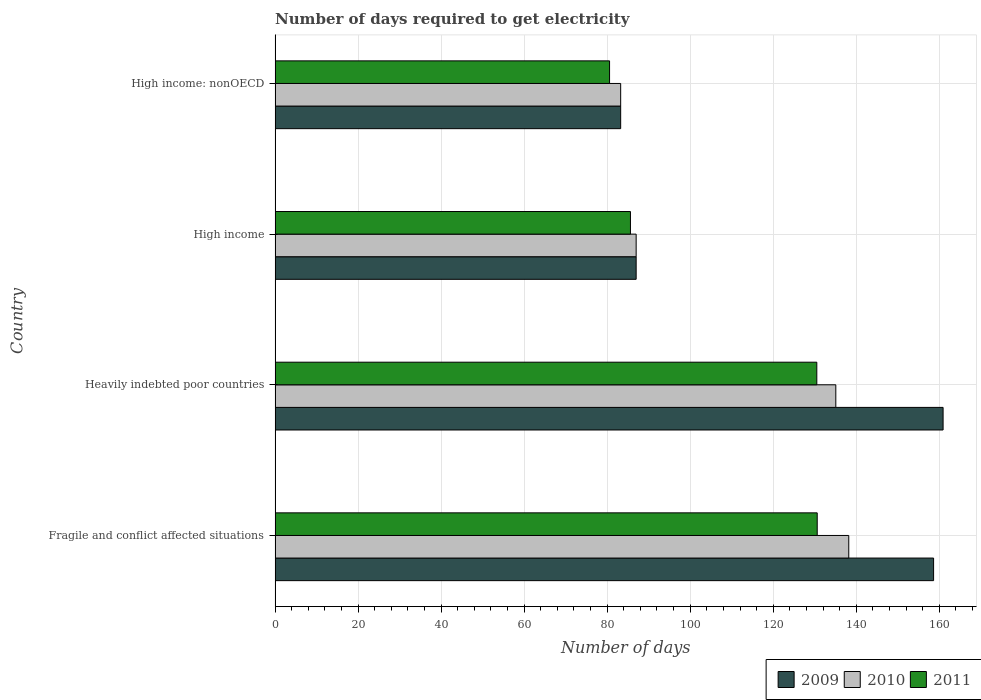Are the number of bars per tick equal to the number of legend labels?
Provide a short and direct response. Yes. Are the number of bars on each tick of the Y-axis equal?
Provide a succinct answer. Yes. How many bars are there on the 2nd tick from the bottom?
Make the answer very short. 3. What is the label of the 3rd group of bars from the top?
Give a very brief answer. Heavily indebted poor countries. What is the number of days required to get electricity in in 2011 in Fragile and conflict affected situations?
Your answer should be compact. 130.6. Across all countries, what is the maximum number of days required to get electricity in in 2011?
Give a very brief answer. 130.6. Across all countries, what is the minimum number of days required to get electricity in in 2011?
Give a very brief answer. 80.58. In which country was the number of days required to get electricity in in 2009 maximum?
Provide a short and direct response. Heavily indebted poor countries. In which country was the number of days required to get electricity in in 2009 minimum?
Offer a very short reply. High income: nonOECD. What is the total number of days required to get electricity in in 2011 in the graph?
Provide a succinct answer. 427.28. What is the difference between the number of days required to get electricity in in 2010 in Fragile and conflict affected situations and that in Heavily indebted poor countries?
Ensure brevity in your answer.  3.12. What is the difference between the number of days required to get electricity in in 2009 in Heavily indebted poor countries and the number of days required to get electricity in in 2010 in Fragile and conflict affected situations?
Your response must be concise. 22.72. What is the average number of days required to get electricity in in 2011 per country?
Offer a terse response. 106.82. What is the difference between the number of days required to get electricity in in 2011 and number of days required to get electricity in in 2009 in High income?
Make the answer very short. -1.37. What is the ratio of the number of days required to get electricity in in 2011 in Heavily indebted poor countries to that in High income: nonOECD?
Provide a succinct answer. 1.62. Is the number of days required to get electricity in in 2010 in Fragile and conflict affected situations less than that in Heavily indebted poor countries?
Provide a short and direct response. No. Is the difference between the number of days required to get electricity in in 2011 in Fragile and conflict affected situations and High income greater than the difference between the number of days required to get electricity in in 2009 in Fragile and conflict affected situations and High income?
Your response must be concise. No. What is the difference between the highest and the second highest number of days required to get electricity in in 2009?
Keep it short and to the point. 2.29. What is the difference between the highest and the lowest number of days required to get electricity in in 2011?
Give a very brief answer. 50.02. Is the sum of the number of days required to get electricity in in 2009 in Fragile and conflict affected situations and High income greater than the maximum number of days required to get electricity in in 2011 across all countries?
Provide a succinct answer. Yes. What does the 2nd bar from the bottom in High income: nonOECD represents?
Give a very brief answer. 2010. How many bars are there?
Your answer should be compact. 12. Does the graph contain grids?
Offer a very short reply. Yes. Where does the legend appear in the graph?
Your answer should be very brief. Bottom right. How many legend labels are there?
Your response must be concise. 3. What is the title of the graph?
Your answer should be very brief. Number of days required to get electricity. Does "2007" appear as one of the legend labels in the graph?
Your answer should be compact. No. What is the label or title of the X-axis?
Make the answer very short. Number of days. What is the Number of days in 2009 in Fragile and conflict affected situations?
Ensure brevity in your answer.  158.63. What is the Number of days in 2010 in Fragile and conflict affected situations?
Your answer should be compact. 138.2. What is the Number of days of 2011 in Fragile and conflict affected situations?
Keep it short and to the point. 130.6. What is the Number of days in 2009 in Heavily indebted poor countries?
Offer a very short reply. 160.92. What is the Number of days in 2010 in Heavily indebted poor countries?
Provide a short and direct response. 135.08. What is the Number of days of 2011 in Heavily indebted poor countries?
Your answer should be compact. 130.5. What is the Number of days in 2009 in High income?
Offer a very short reply. 86.98. What is the Number of days of 2010 in High income?
Make the answer very short. 86.98. What is the Number of days in 2011 in High income?
Your answer should be very brief. 85.61. What is the Number of days of 2009 in High income: nonOECD?
Your answer should be very brief. 83.25. What is the Number of days in 2010 in High income: nonOECD?
Provide a short and direct response. 83.25. What is the Number of days of 2011 in High income: nonOECD?
Keep it short and to the point. 80.58. Across all countries, what is the maximum Number of days in 2009?
Provide a succinct answer. 160.92. Across all countries, what is the maximum Number of days of 2010?
Your answer should be compact. 138.2. Across all countries, what is the maximum Number of days in 2011?
Provide a succinct answer. 130.6. Across all countries, what is the minimum Number of days of 2009?
Your answer should be very brief. 83.25. Across all countries, what is the minimum Number of days in 2010?
Offer a very short reply. 83.25. Across all countries, what is the minimum Number of days of 2011?
Ensure brevity in your answer.  80.58. What is the total Number of days in 2009 in the graph?
Your answer should be compact. 489.79. What is the total Number of days in 2010 in the graph?
Offer a terse response. 443.51. What is the total Number of days of 2011 in the graph?
Ensure brevity in your answer.  427.28. What is the difference between the Number of days in 2009 in Fragile and conflict affected situations and that in Heavily indebted poor countries?
Offer a very short reply. -2.29. What is the difference between the Number of days in 2010 in Fragile and conflict affected situations and that in Heavily indebted poor countries?
Provide a short and direct response. 3.12. What is the difference between the Number of days in 2011 in Fragile and conflict affected situations and that in Heavily indebted poor countries?
Your answer should be very brief. 0.1. What is the difference between the Number of days of 2009 in Fragile and conflict affected situations and that in High income?
Ensure brevity in your answer.  71.65. What is the difference between the Number of days of 2010 in Fragile and conflict affected situations and that in High income?
Your answer should be compact. 51.22. What is the difference between the Number of days in 2011 in Fragile and conflict affected situations and that in High income?
Ensure brevity in your answer.  44.99. What is the difference between the Number of days of 2009 in Fragile and conflict affected situations and that in High income: nonOECD?
Give a very brief answer. 75.38. What is the difference between the Number of days in 2010 in Fragile and conflict affected situations and that in High income: nonOECD?
Provide a succinct answer. 54.95. What is the difference between the Number of days of 2011 in Fragile and conflict affected situations and that in High income: nonOECD?
Offer a terse response. 50.02. What is the difference between the Number of days in 2009 in Heavily indebted poor countries and that in High income?
Ensure brevity in your answer.  73.94. What is the difference between the Number of days of 2010 in Heavily indebted poor countries and that in High income?
Give a very brief answer. 48.1. What is the difference between the Number of days of 2011 in Heavily indebted poor countries and that in High income?
Keep it short and to the point. 44.89. What is the difference between the Number of days in 2009 in Heavily indebted poor countries and that in High income: nonOECD?
Your answer should be compact. 77.67. What is the difference between the Number of days of 2010 in Heavily indebted poor countries and that in High income: nonOECD?
Your answer should be compact. 51.83. What is the difference between the Number of days of 2011 in Heavily indebted poor countries and that in High income: nonOECD?
Provide a succinct answer. 49.92. What is the difference between the Number of days of 2009 in High income and that in High income: nonOECD?
Your answer should be very brief. 3.73. What is the difference between the Number of days of 2010 in High income and that in High income: nonOECD?
Provide a succinct answer. 3.73. What is the difference between the Number of days in 2011 in High income and that in High income: nonOECD?
Provide a short and direct response. 5.03. What is the difference between the Number of days of 2009 in Fragile and conflict affected situations and the Number of days of 2010 in Heavily indebted poor countries?
Make the answer very short. 23.55. What is the difference between the Number of days of 2009 in Fragile and conflict affected situations and the Number of days of 2011 in Heavily indebted poor countries?
Offer a terse response. 28.13. What is the difference between the Number of days of 2009 in Fragile and conflict affected situations and the Number of days of 2010 in High income?
Give a very brief answer. 71.65. What is the difference between the Number of days of 2009 in Fragile and conflict affected situations and the Number of days of 2011 in High income?
Keep it short and to the point. 73.03. What is the difference between the Number of days of 2010 in Fragile and conflict affected situations and the Number of days of 2011 in High income?
Your response must be concise. 52.59. What is the difference between the Number of days of 2009 in Fragile and conflict affected situations and the Number of days of 2010 in High income: nonOECD?
Your answer should be very brief. 75.38. What is the difference between the Number of days of 2009 in Fragile and conflict affected situations and the Number of days of 2011 in High income: nonOECD?
Provide a short and direct response. 78.06. What is the difference between the Number of days in 2010 in Fragile and conflict affected situations and the Number of days in 2011 in High income: nonOECD?
Ensure brevity in your answer.  57.62. What is the difference between the Number of days of 2009 in Heavily indebted poor countries and the Number of days of 2010 in High income?
Give a very brief answer. 73.94. What is the difference between the Number of days in 2009 in Heavily indebted poor countries and the Number of days in 2011 in High income?
Your response must be concise. 75.31. What is the difference between the Number of days in 2010 in Heavily indebted poor countries and the Number of days in 2011 in High income?
Provide a short and direct response. 49.47. What is the difference between the Number of days of 2009 in Heavily indebted poor countries and the Number of days of 2010 in High income: nonOECD?
Ensure brevity in your answer.  77.67. What is the difference between the Number of days in 2009 in Heavily indebted poor countries and the Number of days in 2011 in High income: nonOECD?
Offer a very short reply. 80.34. What is the difference between the Number of days of 2010 in Heavily indebted poor countries and the Number of days of 2011 in High income: nonOECD?
Make the answer very short. 54.5. What is the difference between the Number of days of 2009 in High income and the Number of days of 2010 in High income: nonOECD?
Ensure brevity in your answer.  3.73. What is the difference between the Number of days in 2009 in High income and the Number of days in 2011 in High income: nonOECD?
Keep it short and to the point. 6.4. What is the difference between the Number of days of 2010 in High income and the Number of days of 2011 in High income: nonOECD?
Give a very brief answer. 6.4. What is the average Number of days in 2009 per country?
Your answer should be compact. 122.45. What is the average Number of days in 2010 per country?
Your response must be concise. 110.88. What is the average Number of days of 2011 per country?
Provide a succinct answer. 106.82. What is the difference between the Number of days in 2009 and Number of days in 2010 in Fragile and conflict affected situations?
Make the answer very short. 20.43. What is the difference between the Number of days in 2009 and Number of days in 2011 in Fragile and conflict affected situations?
Your response must be concise. 28.03. What is the difference between the Number of days in 2009 and Number of days in 2010 in Heavily indebted poor countries?
Make the answer very short. 25.84. What is the difference between the Number of days of 2009 and Number of days of 2011 in Heavily indebted poor countries?
Keep it short and to the point. 30.42. What is the difference between the Number of days of 2010 and Number of days of 2011 in Heavily indebted poor countries?
Your answer should be compact. 4.58. What is the difference between the Number of days of 2009 and Number of days of 2010 in High income?
Make the answer very short. 0. What is the difference between the Number of days in 2009 and Number of days in 2011 in High income?
Your answer should be very brief. 1.37. What is the difference between the Number of days of 2010 and Number of days of 2011 in High income?
Offer a terse response. 1.37. What is the difference between the Number of days of 2009 and Number of days of 2010 in High income: nonOECD?
Your response must be concise. 0. What is the difference between the Number of days in 2009 and Number of days in 2011 in High income: nonOECD?
Keep it short and to the point. 2.67. What is the difference between the Number of days of 2010 and Number of days of 2011 in High income: nonOECD?
Make the answer very short. 2.67. What is the ratio of the Number of days in 2009 in Fragile and conflict affected situations to that in Heavily indebted poor countries?
Provide a short and direct response. 0.99. What is the ratio of the Number of days in 2010 in Fragile and conflict affected situations to that in Heavily indebted poor countries?
Provide a succinct answer. 1.02. What is the ratio of the Number of days in 2009 in Fragile and conflict affected situations to that in High income?
Offer a very short reply. 1.82. What is the ratio of the Number of days of 2010 in Fragile and conflict affected situations to that in High income?
Make the answer very short. 1.59. What is the ratio of the Number of days of 2011 in Fragile and conflict affected situations to that in High income?
Your answer should be compact. 1.53. What is the ratio of the Number of days of 2009 in Fragile and conflict affected situations to that in High income: nonOECD?
Make the answer very short. 1.91. What is the ratio of the Number of days of 2010 in Fragile and conflict affected situations to that in High income: nonOECD?
Offer a very short reply. 1.66. What is the ratio of the Number of days in 2011 in Fragile and conflict affected situations to that in High income: nonOECD?
Offer a very short reply. 1.62. What is the ratio of the Number of days of 2009 in Heavily indebted poor countries to that in High income?
Your response must be concise. 1.85. What is the ratio of the Number of days in 2010 in Heavily indebted poor countries to that in High income?
Your response must be concise. 1.55. What is the ratio of the Number of days in 2011 in Heavily indebted poor countries to that in High income?
Provide a succinct answer. 1.52. What is the ratio of the Number of days in 2009 in Heavily indebted poor countries to that in High income: nonOECD?
Offer a very short reply. 1.93. What is the ratio of the Number of days in 2010 in Heavily indebted poor countries to that in High income: nonOECD?
Offer a very short reply. 1.62. What is the ratio of the Number of days in 2011 in Heavily indebted poor countries to that in High income: nonOECD?
Make the answer very short. 1.62. What is the ratio of the Number of days in 2009 in High income to that in High income: nonOECD?
Your answer should be compact. 1.04. What is the ratio of the Number of days of 2010 in High income to that in High income: nonOECD?
Keep it short and to the point. 1.04. What is the ratio of the Number of days in 2011 in High income to that in High income: nonOECD?
Ensure brevity in your answer.  1.06. What is the difference between the highest and the second highest Number of days in 2009?
Provide a succinct answer. 2.29. What is the difference between the highest and the second highest Number of days of 2010?
Your response must be concise. 3.12. What is the difference between the highest and the lowest Number of days in 2009?
Make the answer very short. 77.67. What is the difference between the highest and the lowest Number of days of 2010?
Ensure brevity in your answer.  54.95. What is the difference between the highest and the lowest Number of days of 2011?
Provide a succinct answer. 50.02. 